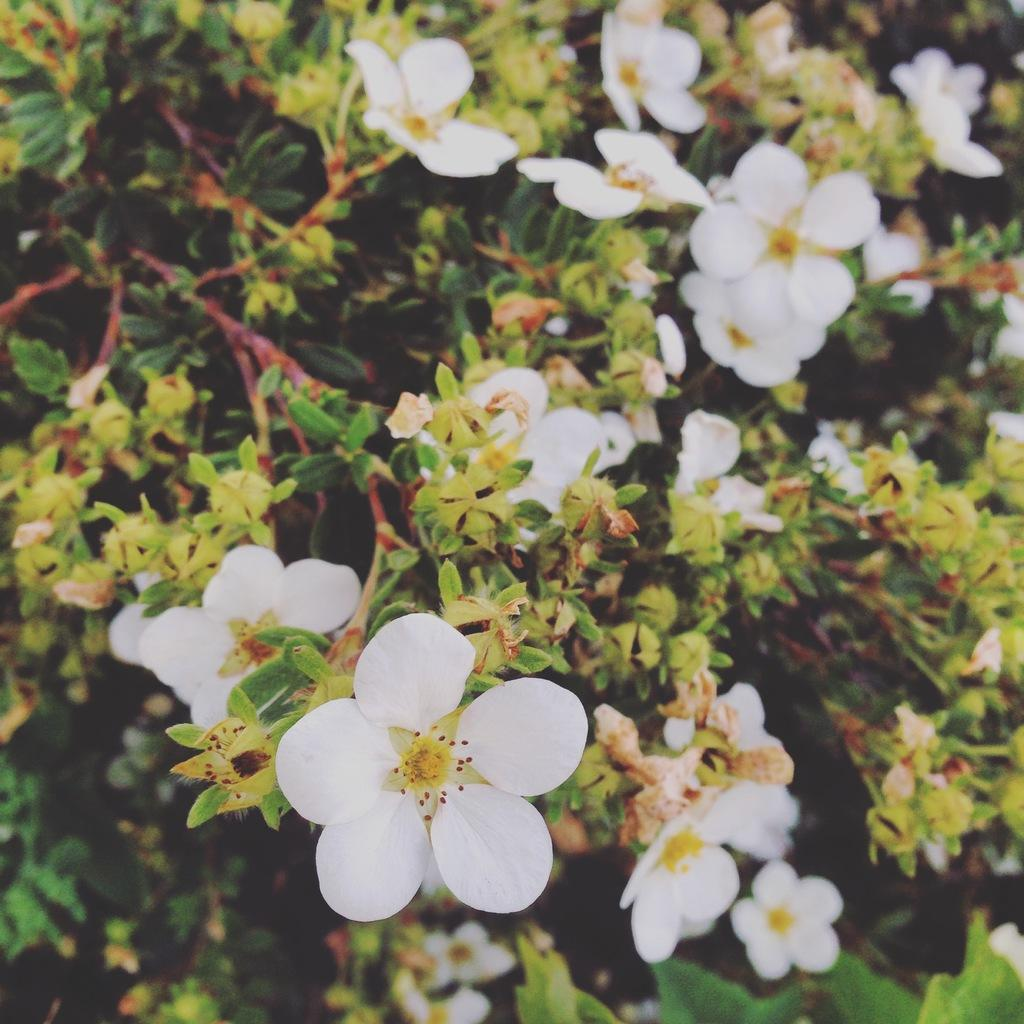What type of flowers are in the image? There are white color flowers in the image. What else can be seen in the image besides the flowers? There are leaves and stems in the image. How does the oven affect the flowers in the image? There is no oven present in the image, so it cannot affect the flowers. 